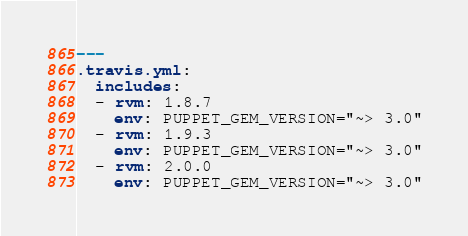<code> <loc_0><loc_0><loc_500><loc_500><_YAML_>---
.travis.yml:
  includes:
  - rvm: 1.8.7
    env: PUPPET_GEM_VERSION="~> 3.0"
  - rvm: 1.9.3
    env: PUPPET_GEM_VERSION="~> 3.0"
  - rvm: 2.0.0
    env: PUPPET_GEM_VERSION="~> 3.0"
</code> 